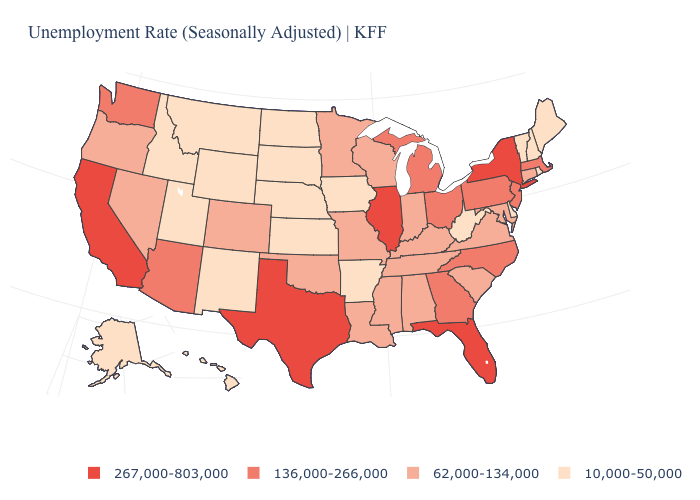Which states hav the highest value in the MidWest?
Short answer required. Illinois. What is the value of North Carolina?
Answer briefly. 136,000-266,000. What is the value of Alaska?
Answer briefly. 10,000-50,000. What is the value of Nevada?
Write a very short answer. 62,000-134,000. Name the states that have a value in the range 136,000-266,000?
Give a very brief answer. Arizona, Georgia, Massachusetts, Michigan, New Jersey, North Carolina, Ohio, Pennsylvania, Washington. What is the value of Louisiana?
Concise answer only. 62,000-134,000. What is the value of Wisconsin?
Quick response, please. 62,000-134,000. Does the first symbol in the legend represent the smallest category?
Answer briefly. No. What is the value of Nevada?
Concise answer only. 62,000-134,000. What is the lowest value in the West?
Concise answer only. 10,000-50,000. Does New Mexico have the highest value in the West?
Quick response, please. No. Name the states that have a value in the range 62,000-134,000?
Short answer required. Alabama, Colorado, Connecticut, Indiana, Kentucky, Louisiana, Maryland, Minnesota, Mississippi, Missouri, Nevada, Oklahoma, Oregon, South Carolina, Tennessee, Virginia, Wisconsin. What is the value of Louisiana?
Concise answer only. 62,000-134,000. What is the value of Montana?
Answer briefly. 10,000-50,000. Which states have the highest value in the USA?
Answer briefly. California, Florida, Illinois, New York, Texas. 